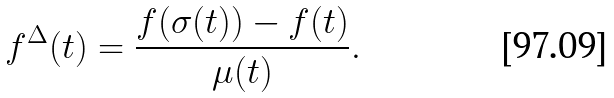Convert formula to latex. <formula><loc_0><loc_0><loc_500><loc_500>f ^ { \Delta } ( t ) = \frac { f ( \sigma ( t ) ) - f ( t ) } { \mu ( t ) } .</formula> 